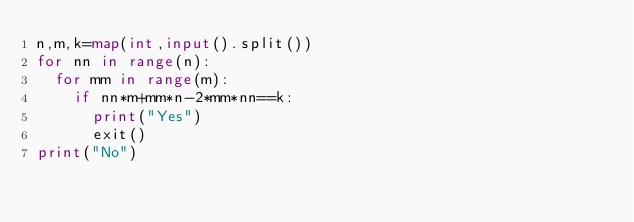<code> <loc_0><loc_0><loc_500><loc_500><_Python_>n,m,k=map(int,input().split())
for nn in range(n):
	for mm in range(m):
		if nn*m+mm*n-2*mm*nn==k:
			print("Yes")
			exit()
print("No")

</code> 